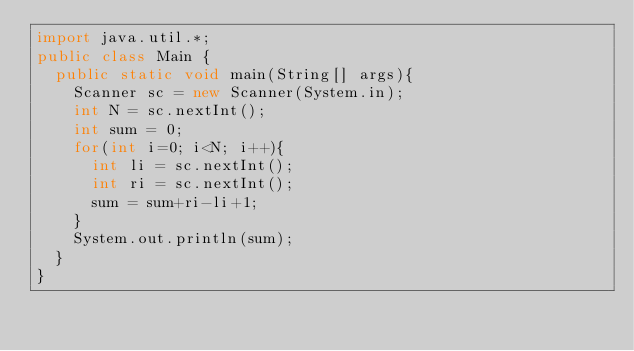<code> <loc_0><loc_0><loc_500><loc_500><_Java_>import java.util.*;
public class Main {
  public static void main(String[] args){
    Scanner sc = new Scanner(System.in);
    int N = sc.nextInt();
    int sum = 0;
    for(int i=0; i<N; i++){
      int li = sc.nextInt();
      int ri = sc.nextInt();
      sum = sum+ri-li+1;
    }
    System.out.println(sum);
  }
}
</code> 